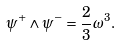Convert formula to latex. <formula><loc_0><loc_0><loc_500><loc_500>\psi ^ { + } \wedge \psi ^ { - } = \frac { 2 } { 3 } \omega ^ { 3 } .</formula> 